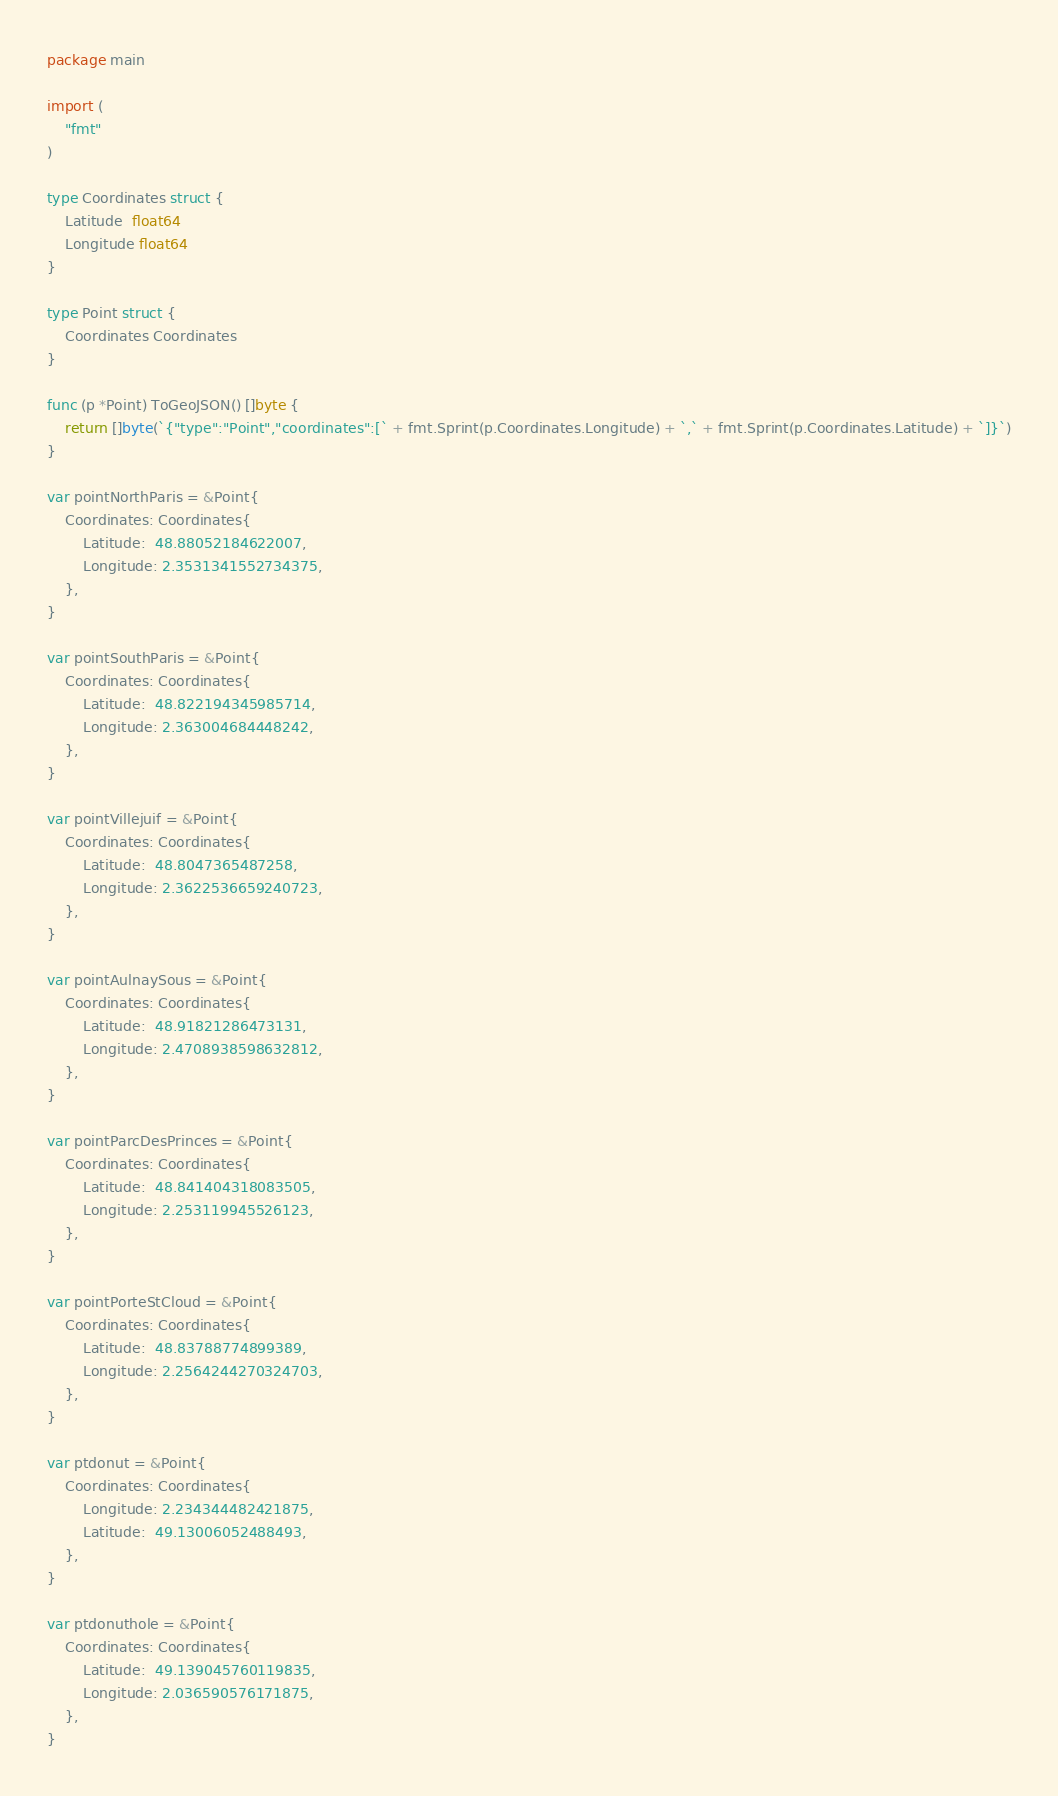Convert code to text. <code><loc_0><loc_0><loc_500><loc_500><_Go_>package main

import (
	"fmt"
)

type Coordinates struct {
	Latitude  float64
	Longitude float64
}

type Point struct {
	Coordinates Coordinates
}

func (p *Point) ToGeoJSON() []byte {
	return []byte(`{"type":"Point","coordinates":[` + fmt.Sprint(p.Coordinates.Longitude) + `,` + fmt.Sprint(p.Coordinates.Latitude) + `]}`)
}

var pointNorthParis = &Point{
	Coordinates: Coordinates{
		Latitude:  48.88052184622007,
		Longitude: 2.3531341552734375,
	},
}

var pointSouthParis = &Point{
	Coordinates: Coordinates{
		Latitude:  48.822194345985714,
		Longitude: 2.363004684448242,
	},
}

var pointVillejuif = &Point{
	Coordinates: Coordinates{
		Latitude:  48.8047365487258,
		Longitude: 2.3622536659240723,
	},
}

var pointAulnaySous = &Point{
	Coordinates: Coordinates{
		Latitude:  48.91821286473131,
		Longitude: 2.4708938598632812,
	},
}

var pointParcDesPrinces = &Point{
	Coordinates: Coordinates{
		Latitude:  48.841404318083505,
		Longitude: 2.253119945526123,
	},
}

var pointPorteStCloud = &Point{
	Coordinates: Coordinates{
		Latitude:  48.83788774899389,
		Longitude: 2.2564244270324703,
	},
}

var ptdonut = &Point{
	Coordinates: Coordinates{
		Longitude: 2.234344482421875,
		Latitude:  49.13006052488493,
	},
}

var ptdonuthole = &Point{
	Coordinates: Coordinates{
		Latitude:  49.139045760119835,
		Longitude: 2.036590576171875,
	},
}
</code> 